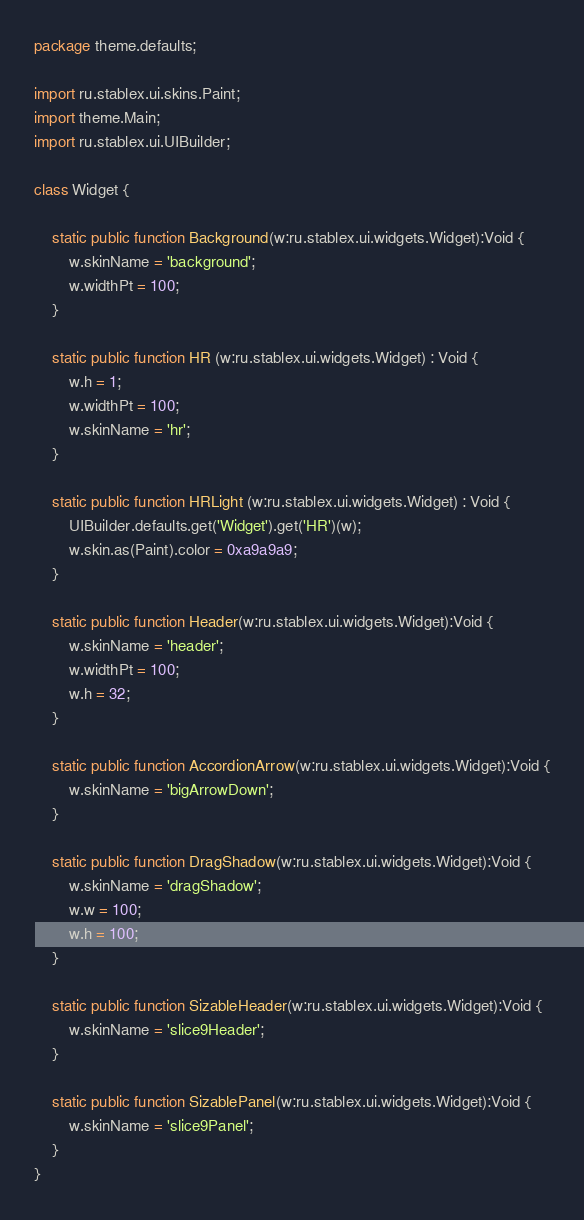Convert code to text. <code><loc_0><loc_0><loc_500><loc_500><_Haxe_>package theme.defaults;

import ru.stablex.ui.skins.Paint;
import theme.Main;
import ru.stablex.ui.UIBuilder;

class Widget {
	
	static public function Background(w:ru.stablex.ui.widgets.Widget):Void {
		w.skinName = 'background';
		w.widthPt = 100;
	}
	
    static public function HR (w:ru.stablex.ui.widgets.Widget) : Void {
        w.h = 1;
        w.widthPt = 100;
        w.skinName = 'hr';
    }

    static public function HRLight (w:ru.stablex.ui.widgets.Widget) : Void {
        UIBuilder.defaults.get('Widget').get('HR')(w);
        w.skin.as(Paint).color = 0xa9a9a9;
    }
	
	static public function Header(w:ru.stablex.ui.widgets.Widget):Void {
		w.skinName = 'header';
		w.widthPt = 100;
		w.h = 32;
	}
	
	static public function AccordionArrow(w:ru.stablex.ui.widgets.Widget):Void {
		w.skinName = 'bigArrowDown';
	}
	
	static public function DragShadow(w:ru.stablex.ui.widgets.Widget):Void {
		w.skinName = 'dragShadow';
		w.w = 100;
		w.h = 100;
	}
	
	static public function SizableHeader(w:ru.stablex.ui.widgets.Widget):Void {
		w.skinName = 'slice9Header';
	}
	
	static public function SizablePanel(w:ru.stablex.ui.widgets.Widget):Void {
		w.skinName = 'slice9Panel';
	}
}</code> 